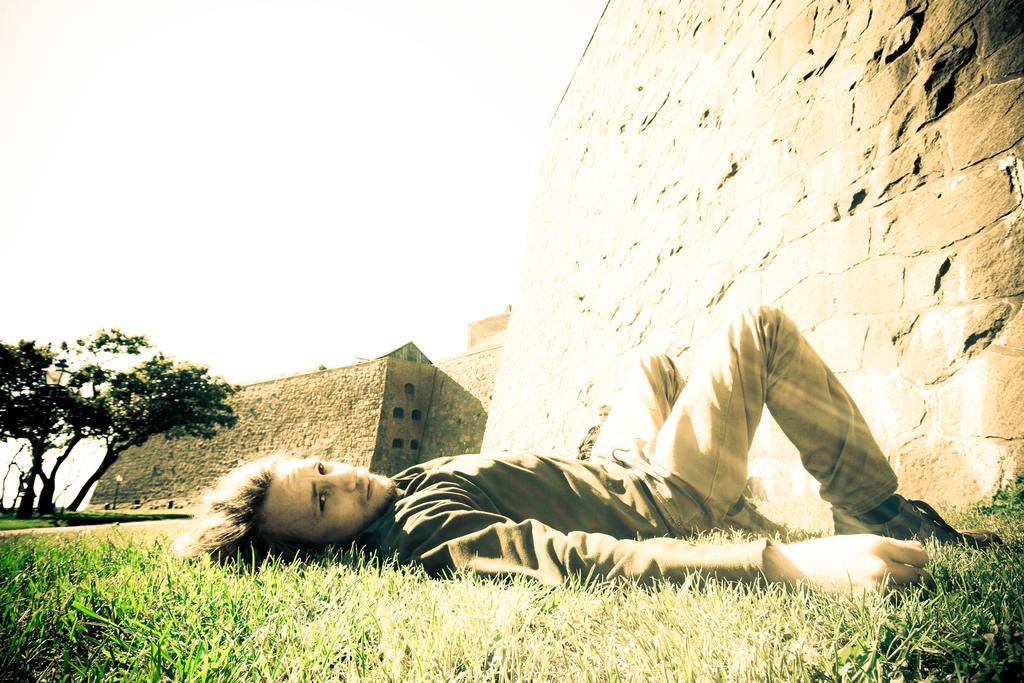Please provide a concise description of this image. In this image in the front there is grass on the ground and there is a man laying on the ground. In the background there are walls and there are trees. 